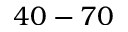Convert formula to latex. <formula><loc_0><loc_0><loc_500><loc_500>4 0 - 7 0</formula> 